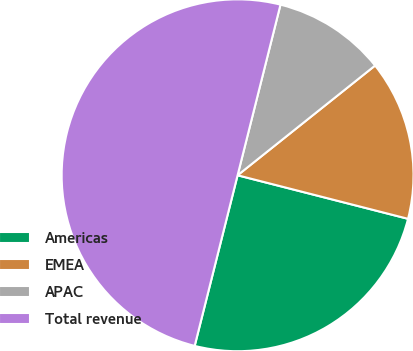<chart> <loc_0><loc_0><loc_500><loc_500><pie_chart><fcel>Americas<fcel>EMEA<fcel>APAC<fcel>Total revenue<nl><fcel>24.94%<fcel>14.7%<fcel>10.36%<fcel>50.0%<nl></chart> 